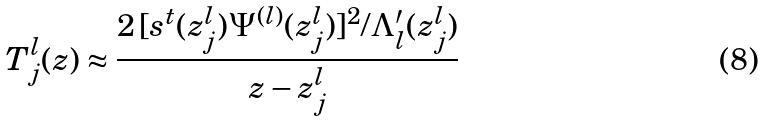Convert formula to latex. <formula><loc_0><loc_0><loc_500><loc_500>T ^ { l } _ { j } ( z ) \approx \frac { 2 \, [ s ^ { t } ( z ^ { l } _ { j } ) \Psi ^ { ( l ) } ( z ^ { l } _ { j } ) ] ^ { 2 } / \Lambda ^ { \prime } _ { l } ( z ^ { l } _ { j } ) } { z - z ^ { l } _ { j } }</formula> 